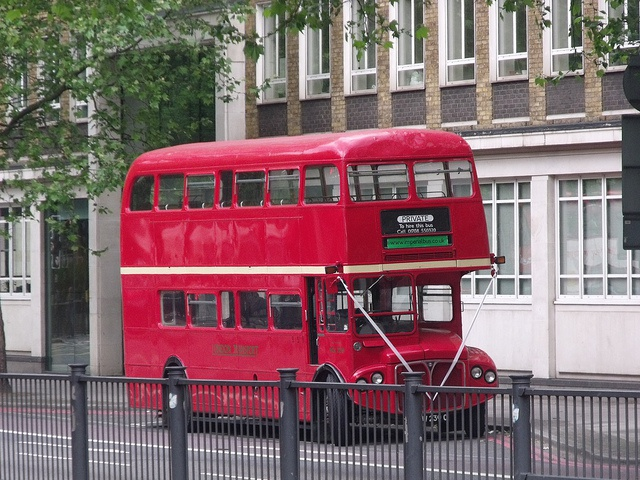Describe the objects in this image and their specific colors. I can see bus in darkgreen, brown, black, and gray tones in this image. 